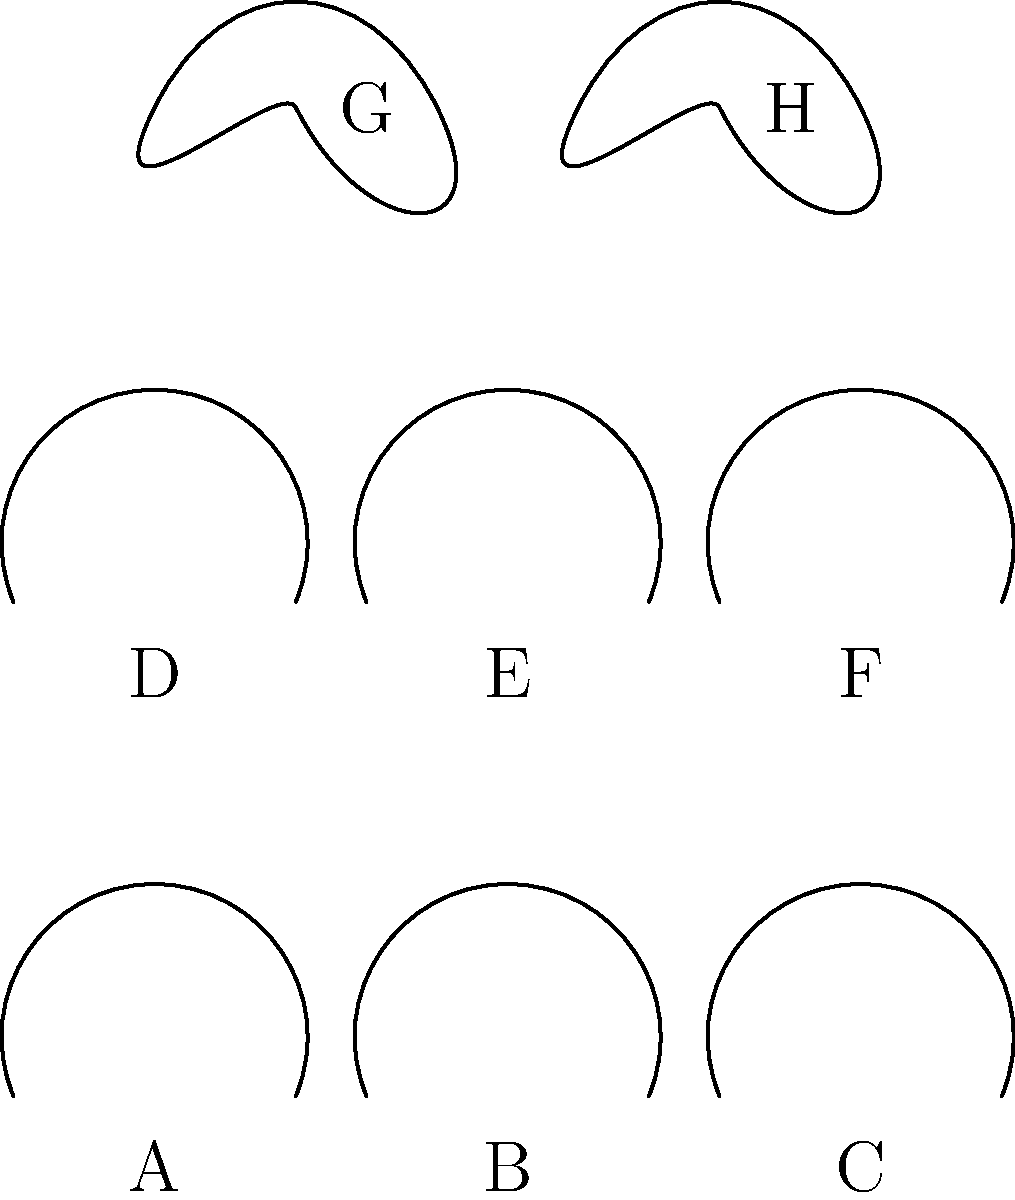In fingerprint analysis, identify the pattern that appears most frequently in the image above. How might this information be relevant in defending a client accused of a crime where fingerprint evidence is presented? To answer this question, we need to follow these steps:

1. Identify the different fingerprint patterns shown:
   - Patterns A, B, and C are arches
   - Patterns D, E, and F are loops
   - Patterns G and H are whorls

2. Count the frequency of each pattern:
   - Arches: 3
   - Loops: 3
   - Whorls: 2

3. Determine the most frequent pattern:
   Both arches and loops appear three times, making them equally the most frequent patterns in the image.

4. Relevance to defending a client:
   As a public defender, understanding the frequency of fingerprint patterns is crucial when fingerprint evidence is presented in a case. Here's how this information can be used:

   a) Probability and uniqueness: The frequency of patterns in the general population affects the uniqueness of a fingerprint. If the client's fingerprint matches a common pattern (like arches or loops), you can argue that this reduces the certainty of identification.

   b) Expert testimony: You can use this knowledge to question forensic experts about the statistical significance of pattern matches, especially if the matched pattern is common.

   c) Alternative suspects: If the crime scene fingerprint is a common pattern, you can argue that it could belong to many individuals, not just your client.

   d) Misidentification risk: Emphasize that common patterns increase the risk of misidentification, especially if the print quality is poor or partial.

   e) Reasonable doubt: Use the frequency of patterns to introduce reasonable doubt about the reliability of fingerprint evidence in this specific case.

By understanding and utilizing this information, you can build a stronger defense strategy that challenges the prosecution's fingerprint evidence, potentially creating reasonable doubt in the minds of the jury.
Answer: Arches and loops (equally frequent); crucial for challenging fingerprint evidence reliability and uniqueness. 